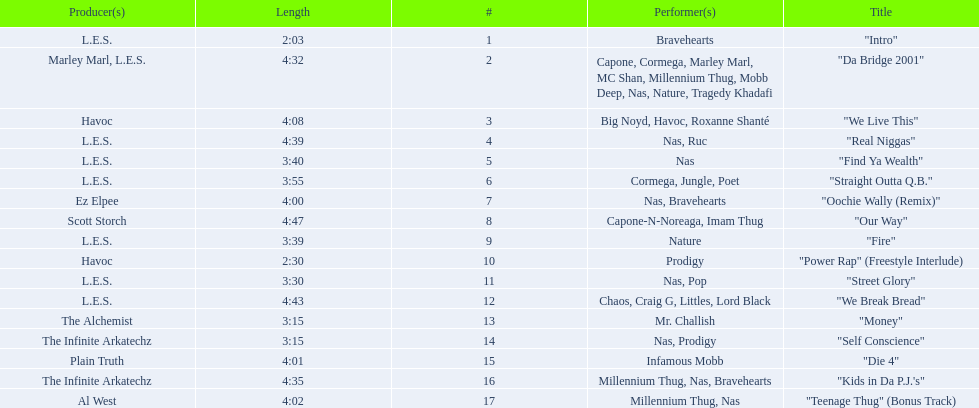How long is the shortest song on the album? 2:03. 